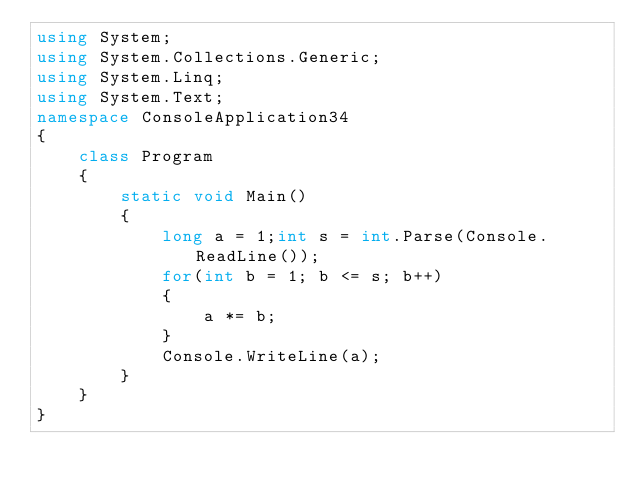Convert code to text. <code><loc_0><loc_0><loc_500><loc_500><_C#_>using System;
using System.Collections.Generic;
using System.Linq;
using System.Text;
namespace ConsoleApplication34
{
    class Program
    {
        static void Main()
        {
            long a = 1;int s = int.Parse(Console.ReadLine());
            for(int b = 1; b <= s; b++)
            {
                a *= b;
            }
            Console.WriteLine(a);
        }
    }
}</code> 